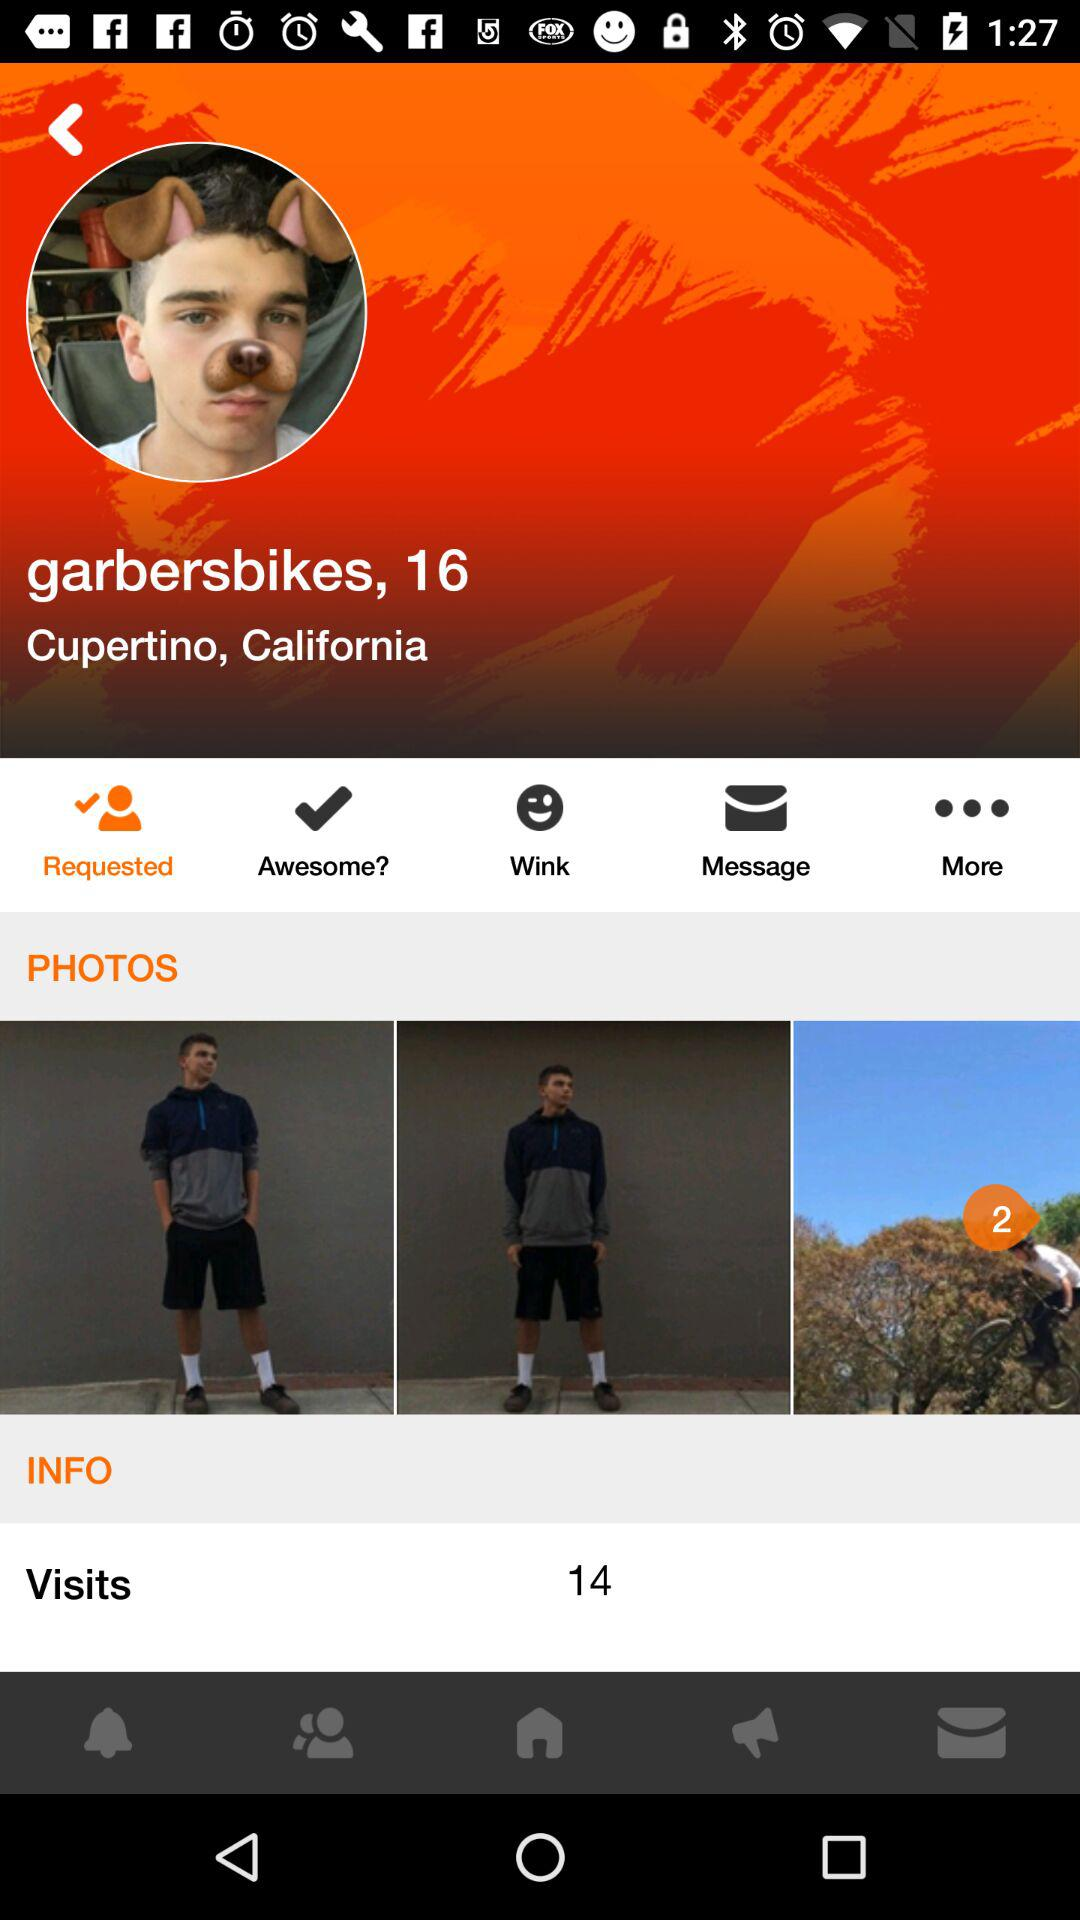How many photos are there in the gallery?
Answer the question using a single word or phrase. 3 